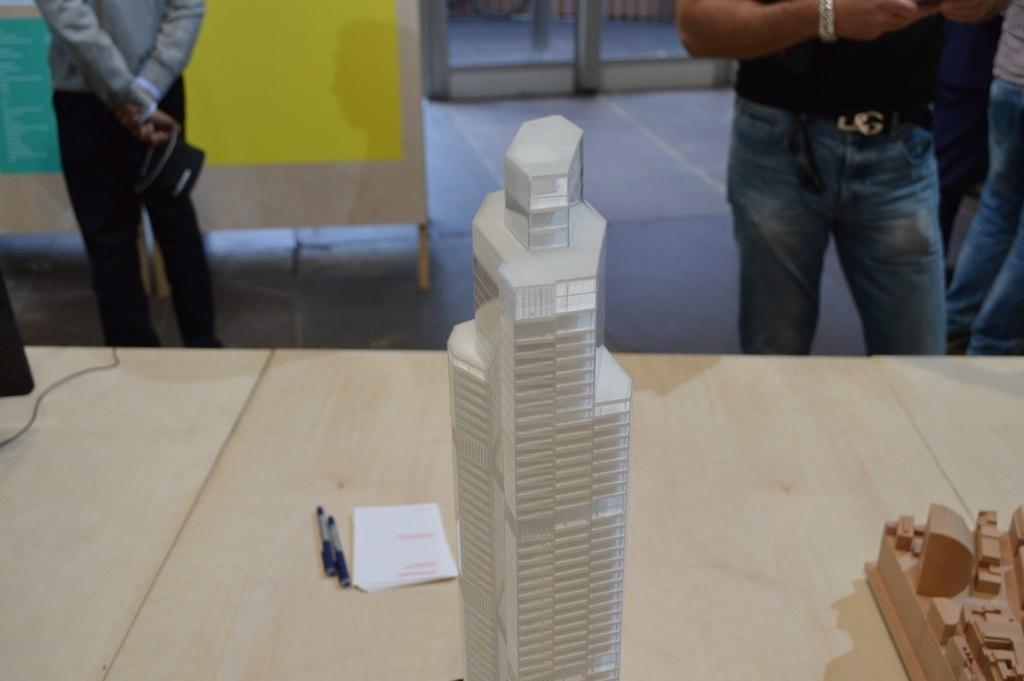Can you describe this image briefly? In the middle it is a glass building, on the right side a man is standing, this person wore blue color trouser. There are pens and a paper on this table. 